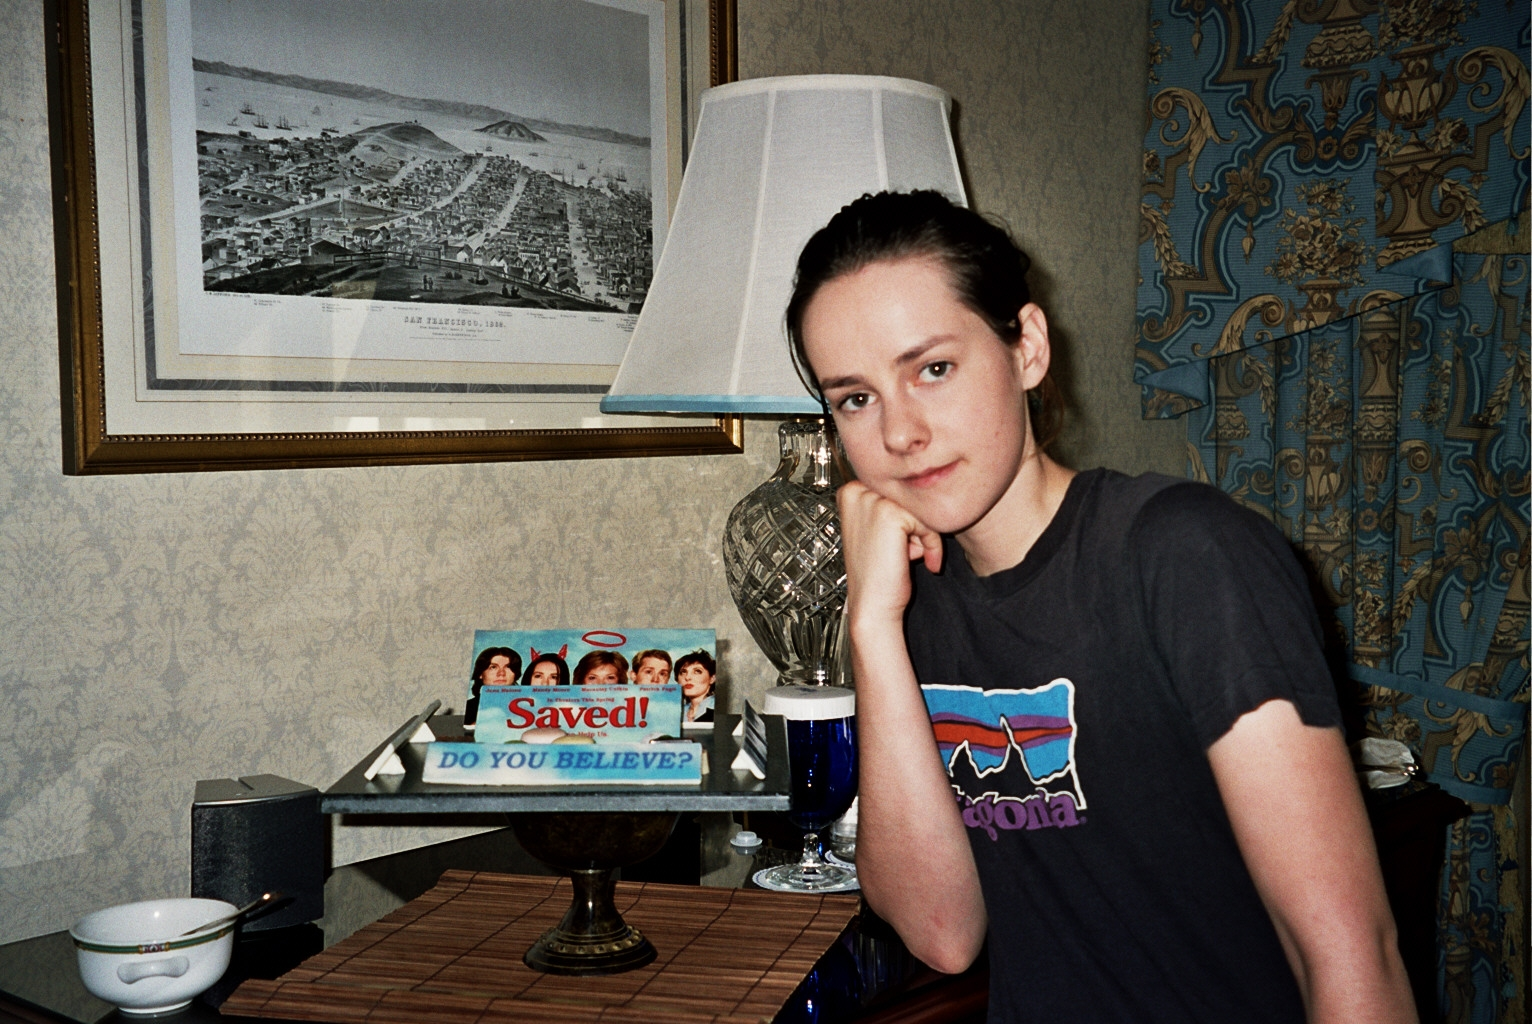Can you describe the atmosphere or mood in this image? The atmosphere in this image is one of relaxed contemplation, as the individual rests thoughtfully with their chin on their hand. The soft light from the ornate table lamp adds a cozy feeling, and the detailed wallpaper and framed artwork lend a distinguished, almost nostalgic ambiance to the scene. 